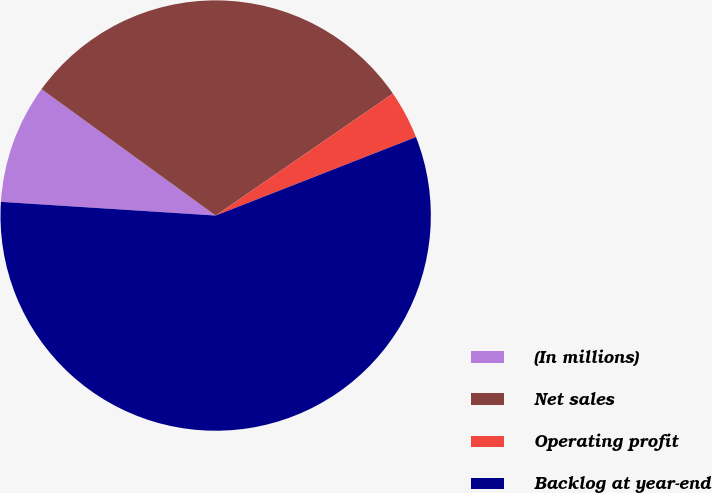Convert chart. <chart><loc_0><loc_0><loc_500><loc_500><pie_chart><fcel>(In millions)<fcel>Net sales<fcel>Operating profit<fcel>Backlog at year-end<nl><fcel>8.98%<fcel>30.41%<fcel>3.65%<fcel>56.95%<nl></chart> 